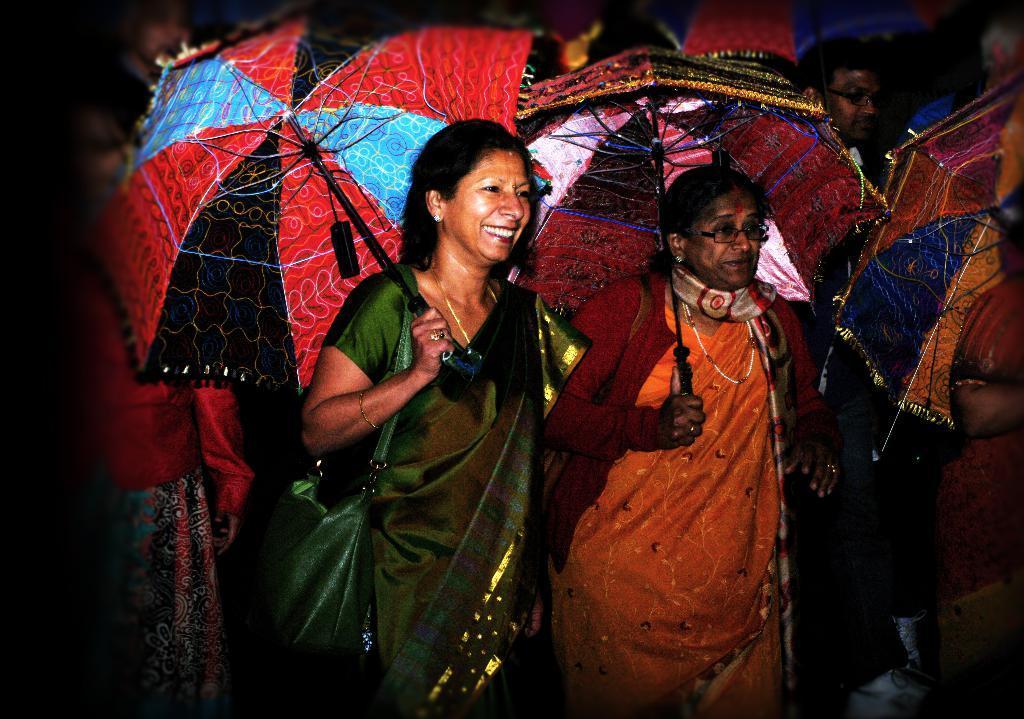Could you give a brief overview of what you see in this image? In this image, we can see two women are holding umbrellas. Here a woman is smiling and wearing bag. Here we can see few people and umbrellas. Left side of the image, we can see a blur view. 